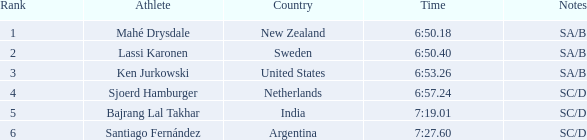What is the sum of the ranks for india? 5.0. 